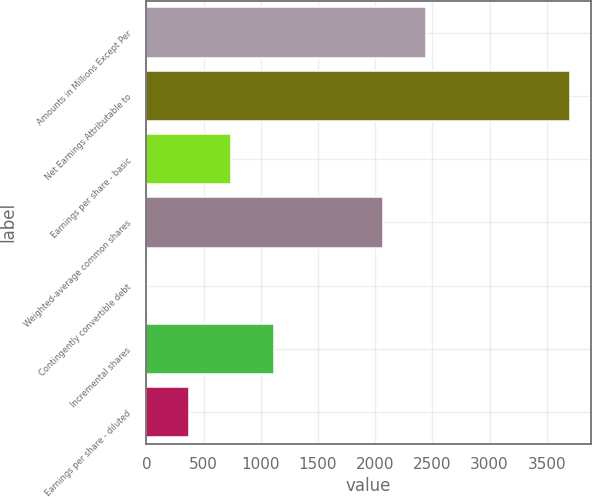Convert chart. <chart><loc_0><loc_0><loc_500><loc_500><bar_chart><fcel>Amounts in Millions Except Per<fcel>Net Earnings Attributable to<fcel>Earnings per share - basic<fcel>Weighted-average common shares<fcel>Contingently convertible debt<fcel>Incremental shares<fcel>Earnings per share - diluted<nl><fcel>2441.6<fcel>3701<fcel>742.6<fcel>2070.8<fcel>1<fcel>1113.4<fcel>371.8<nl></chart> 